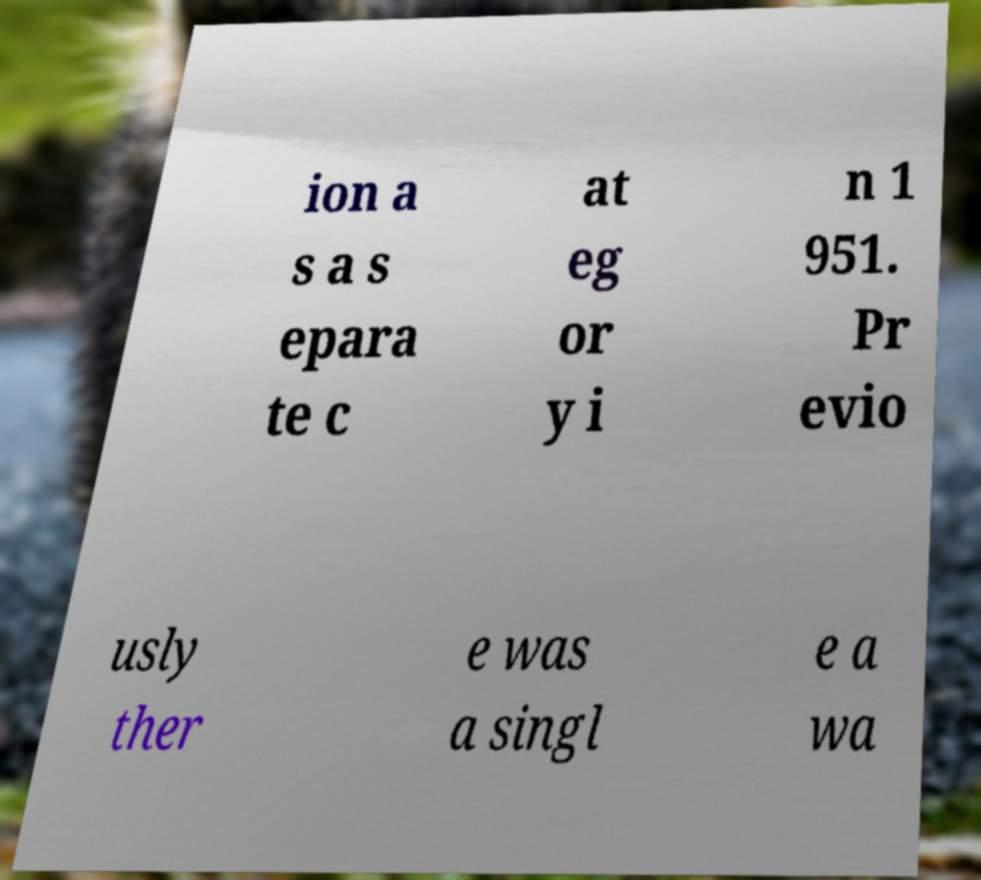I need the written content from this picture converted into text. Can you do that? ion a s a s epara te c at eg or y i n 1 951. Pr evio usly ther e was a singl e a wa 